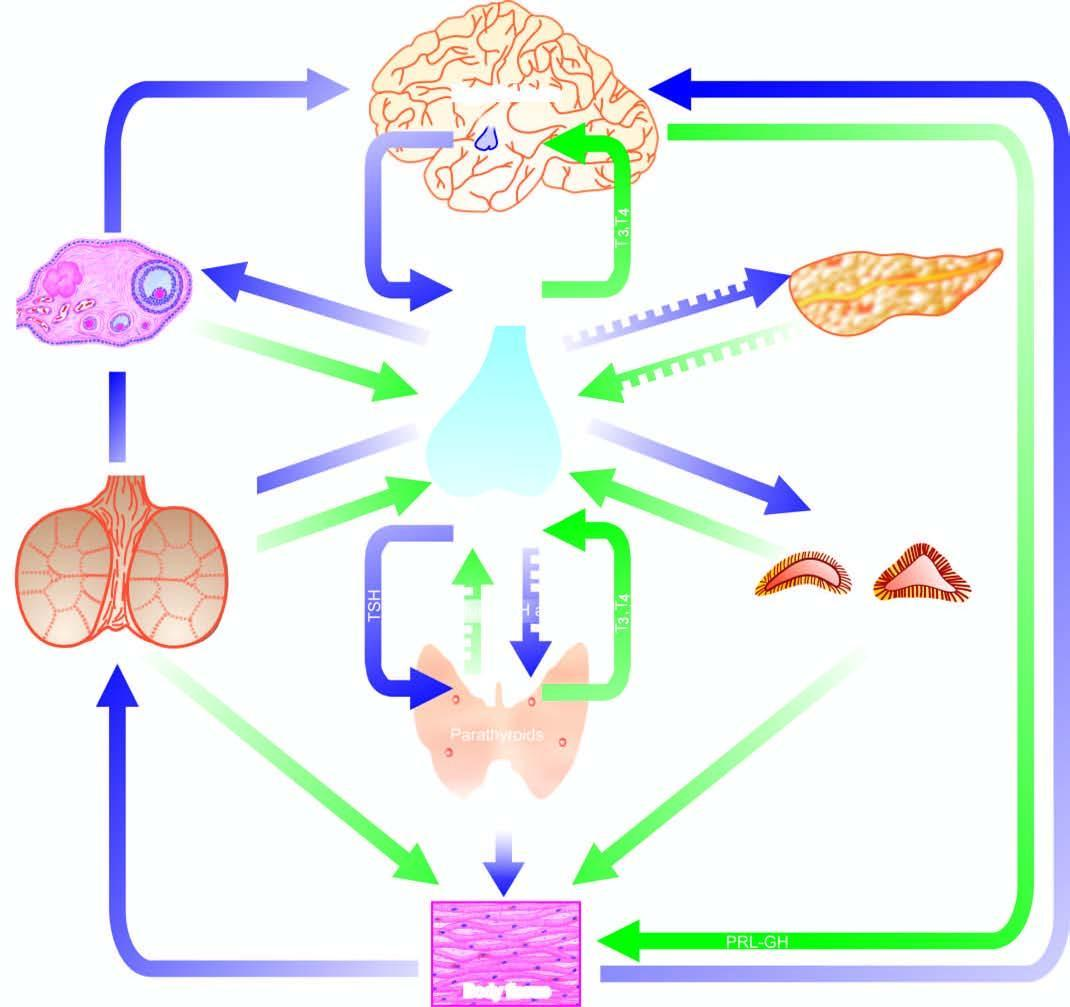do both positive and negative feedback controls exist for each endocrine gland having a regulating hormone?
Answer the question using a single word or phrase. Yes 